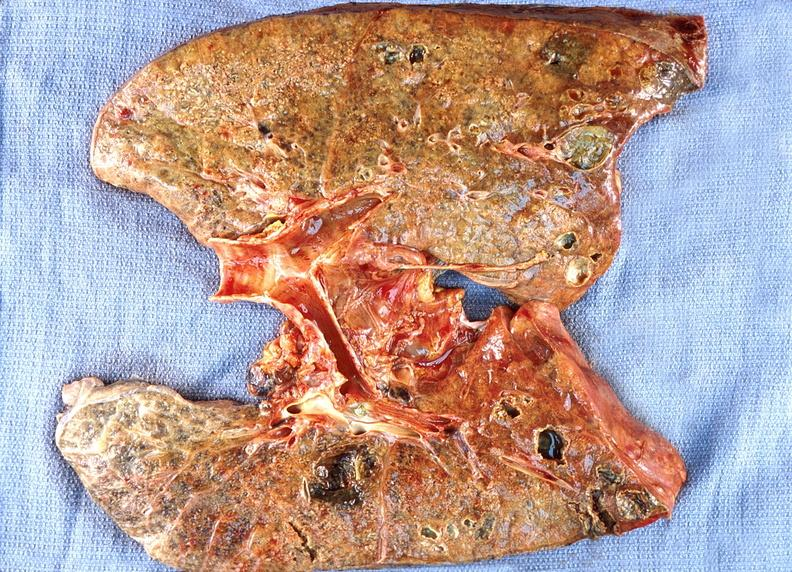what does this image show?
Answer the question using a single word or phrase. Lung abscess 